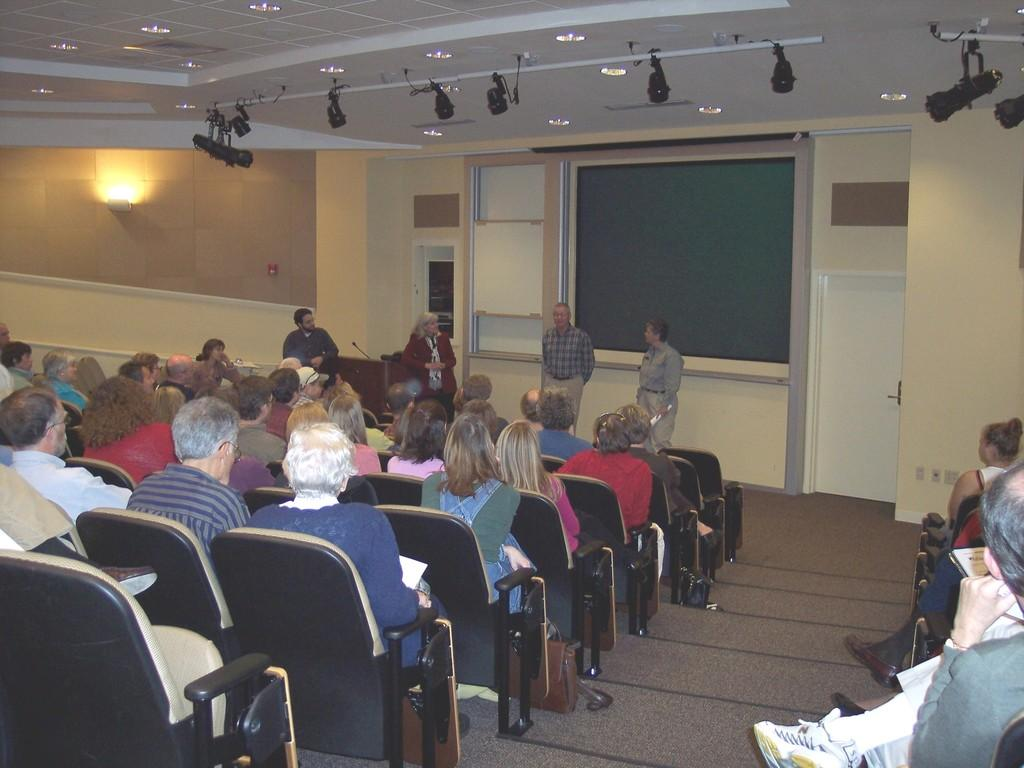What are the people in the image doing? There are people sitting on chairs and people standing in front of the seated people in the image. Can you describe the positions of the people in the image? The people are either sitting on chairs or standing in front of the seated people. How many boats are visible in the image? There are no boats present in the image. What type of sack is being used by the people in the image? There is no sack visible in the image. 